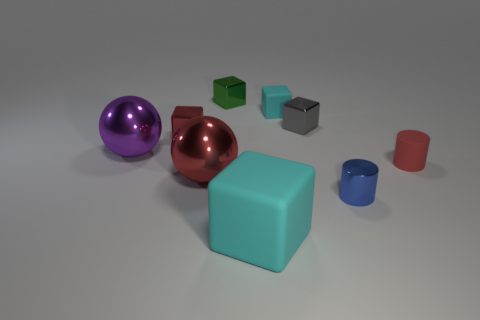Is the big matte object the same color as the tiny rubber block?
Your answer should be compact. Yes. There is a cyan block that is behind the big cyan block; what number of big purple objects are to the right of it?
Offer a terse response. 0. Are there any other things that are the same material as the blue cylinder?
Your response must be concise. Yes. What is the material of the tiny red thing that is right of the cyan matte thing in front of the tiny rubber object that is left of the tiny red rubber thing?
Ensure brevity in your answer.  Rubber. What is the small object that is both to the right of the large cyan matte cube and behind the gray metal block made of?
Give a very brief answer. Rubber. How many big cyan things have the same shape as the tiny cyan object?
Offer a terse response. 1. What size is the purple metallic thing that is left of the matte block that is in front of the tiny metallic cylinder?
Your answer should be very brief. Large. There is a tiny rubber thing that is on the right side of the tiny gray shiny cube; is it the same color as the tiny block in front of the tiny gray cube?
Ensure brevity in your answer.  Yes. How many cylinders are behind the tiny blue cylinder that is in front of the small metallic thing left of the green shiny block?
Provide a succinct answer. 1. How many things are in front of the tiny rubber cylinder and on the left side of the blue metallic thing?
Offer a terse response. 2. 